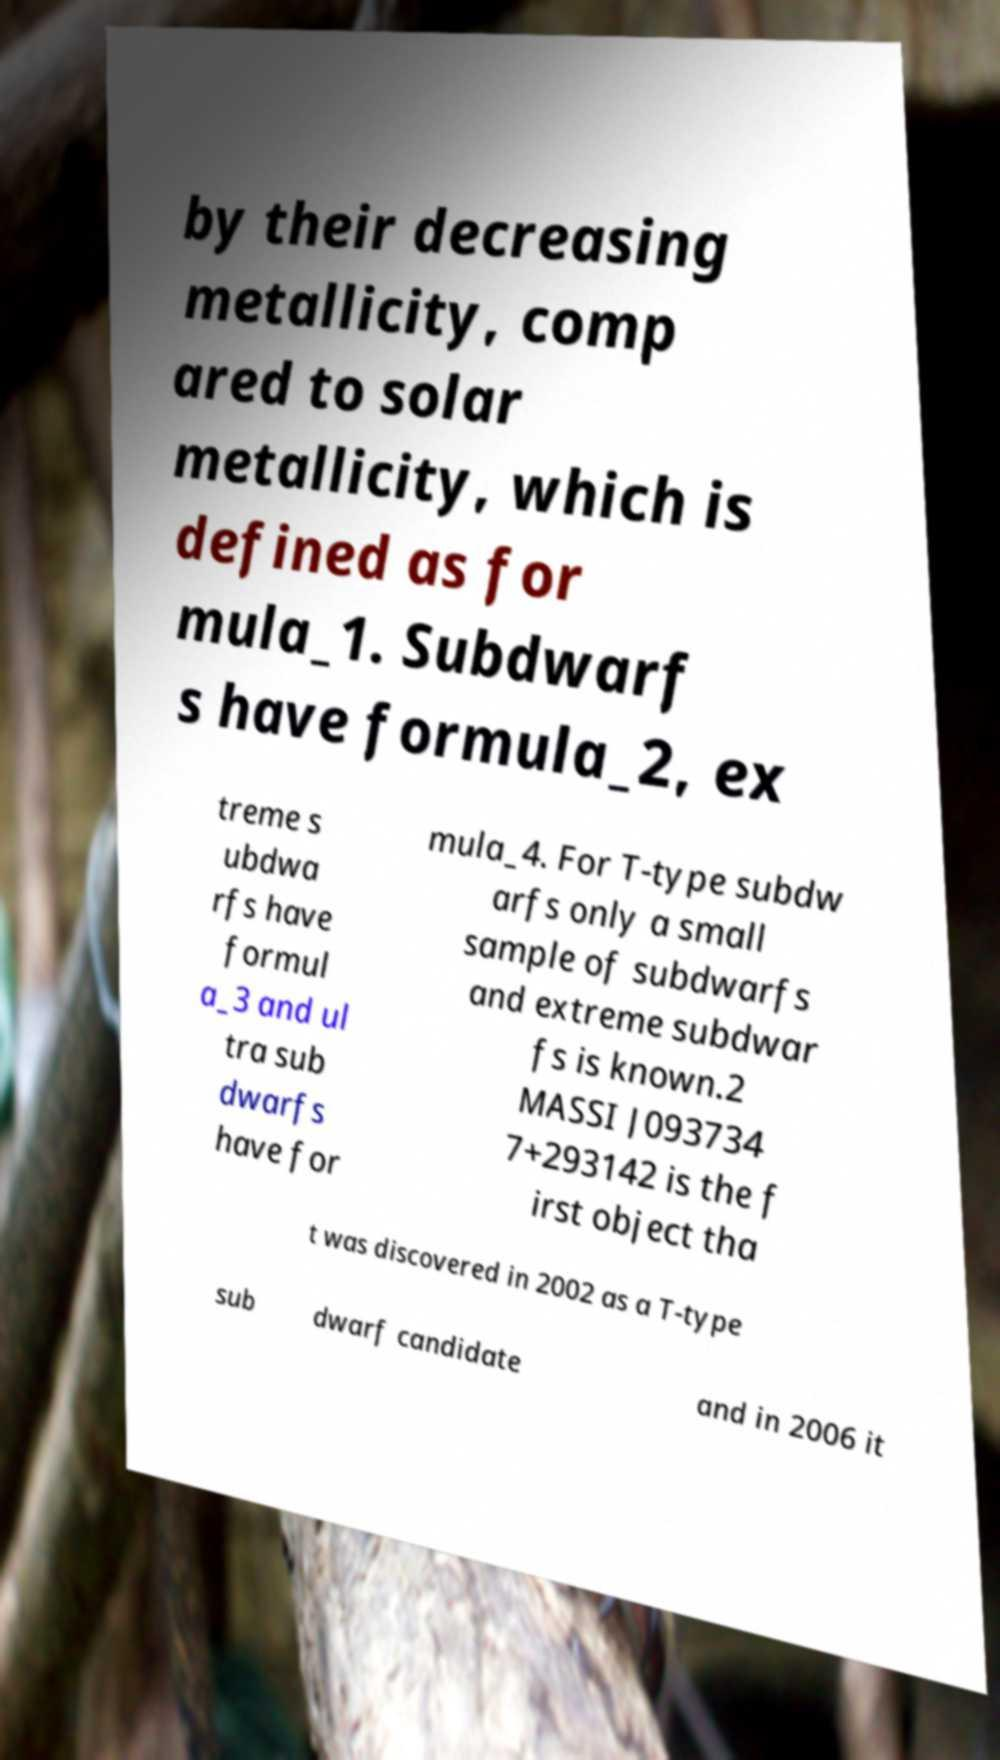There's text embedded in this image that I need extracted. Can you transcribe it verbatim? by their decreasing metallicity, comp ared to solar metallicity, which is defined as for mula_1. Subdwarf s have formula_2, ex treme s ubdwa rfs have formul a_3 and ul tra sub dwarfs have for mula_4. For T-type subdw arfs only a small sample of subdwarfs and extreme subdwar fs is known.2 MASSI J093734 7+293142 is the f irst object tha t was discovered in 2002 as a T-type sub dwarf candidate and in 2006 it 